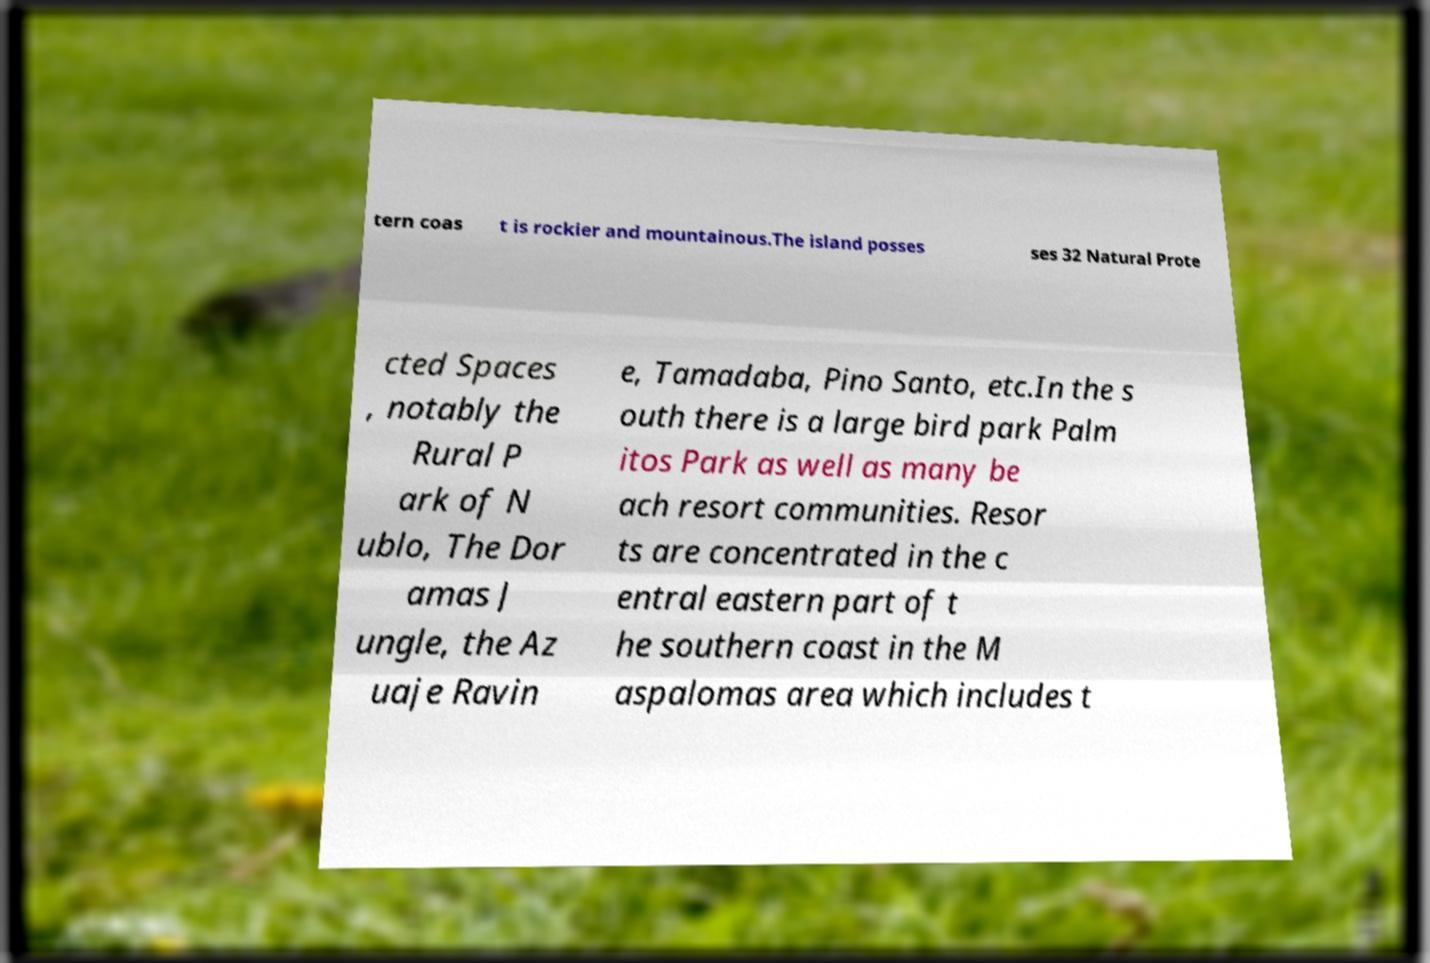Can you read and provide the text displayed in the image?This photo seems to have some interesting text. Can you extract and type it out for me? tern coas t is rockier and mountainous.The island posses ses 32 Natural Prote cted Spaces , notably the Rural P ark of N ublo, The Dor amas J ungle, the Az uaje Ravin e, Tamadaba, Pino Santo, etc.In the s outh there is a large bird park Palm itos Park as well as many be ach resort communities. Resor ts are concentrated in the c entral eastern part of t he southern coast in the M aspalomas area which includes t 